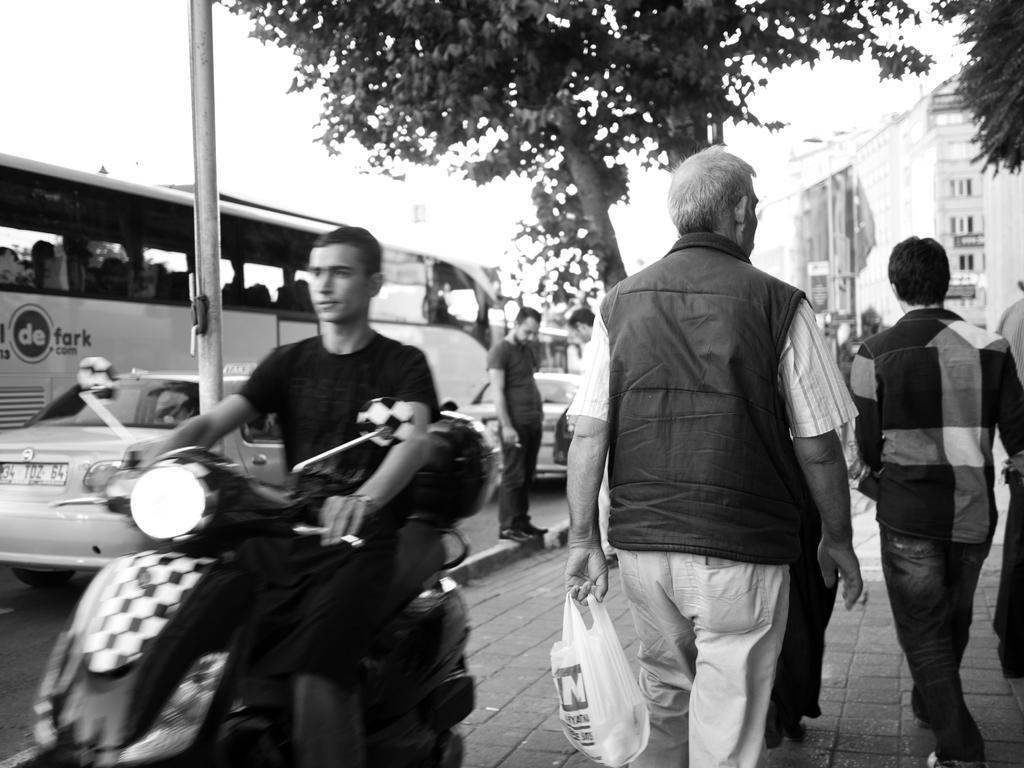How would you summarize this image in a sentence or two? This is a black and white picture. On the right side, we see the people are walking on the footpath. We see a man in the black jacket is holding a white cover in his hands. Beside him, we see a man is riding the bike. On the left side, we see the cars and the bus are moving on the road. Beside that, we see a pole and a tree. We see two men are standing beside the tree. There are buildings in the background. At the top, we see the sky. 